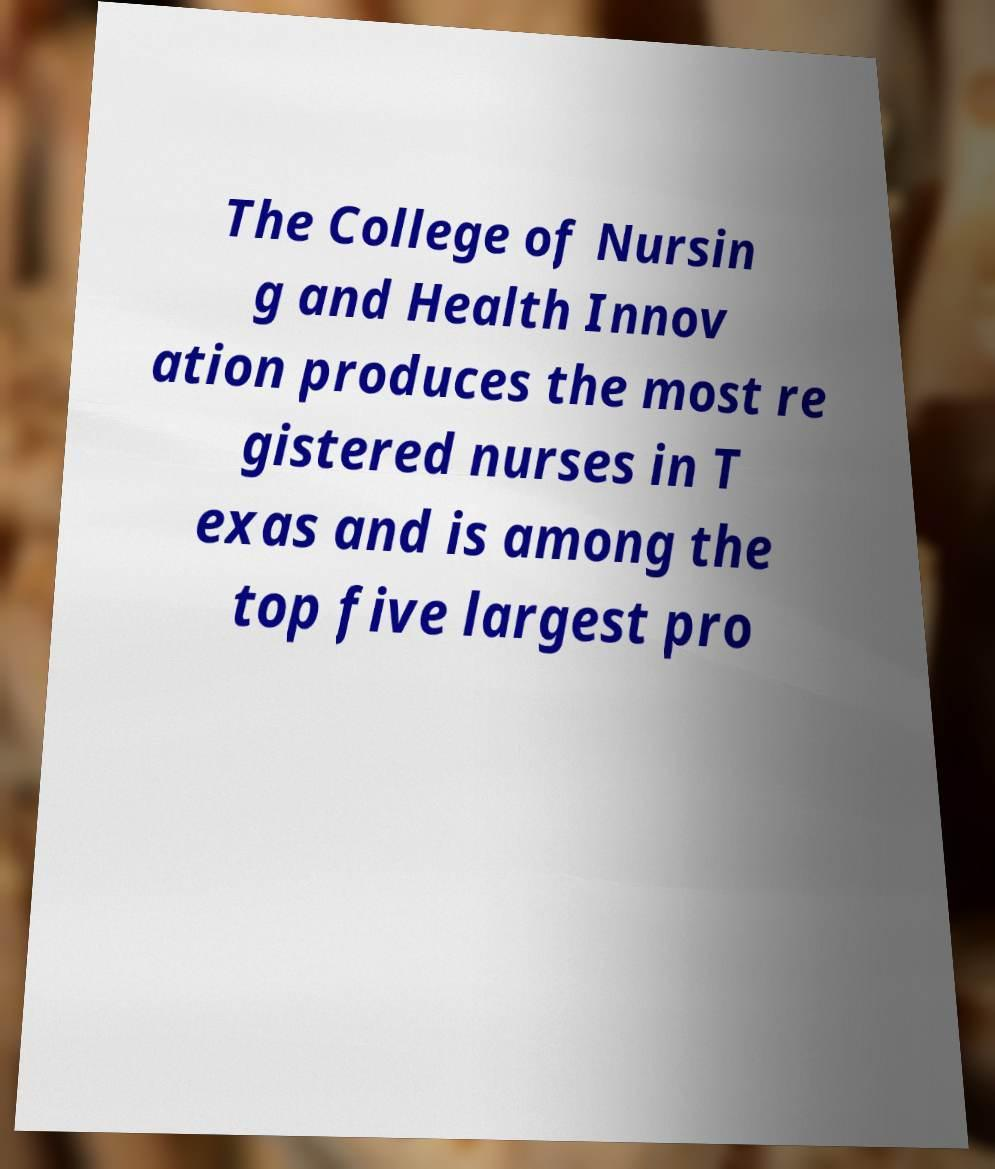Could you assist in decoding the text presented in this image and type it out clearly? The College of Nursin g and Health Innov ation produces the most re gistered nurses in T exas and is among the top five largest pro 